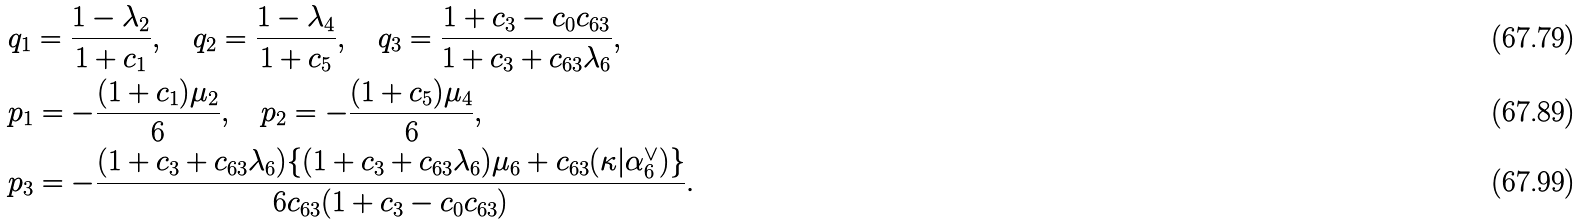Convert formula to latex. <formula><loc_0><loc_0><loc_500><loc_500>& q _ { 1 } = \frac { 1 - \lambda _ { 2 } } { 1 + c _ { 1 } } , \quad q _ { 2 } = \frac { 1 - \lambda _ { 4 } } { 1 + c _ { 5 } } , \quad q _ { 3 } = \frac { 1 + c _ { 3 } - c _ { 0 } c _ { 6 3 } } { 1 + c _ { 3 } + c _ { 6 3 } \lambda _ { 6 } } , \\ & p _ { 1 } = - \frac { ( 1 + c _ { 1 } ) \mu _ { 2 } } { 6 } , \quad p _ { 2 } = - \frac { ( 1 + c _ { 5 } ) \mu _ { 4 } } { 6 } , \\ & p _ { 3 } = - \frac { ( 1 + c _ { 3 } + c _ { 6 3 } \lambda _ { 6 } ) \{ ( 1 + c _ { 3 } + c _ { 6 3 } \lambda _ { 6 } ) \mu _ { 6 } + c _ { 6 3 } ( \kappa | \alpha _ { 6 } ^ { \vee } ) \} } { 6 c _ { 6 3 } ( 1 + c _ { 3 } - c _ { 0 } c _ { 6 3 } ) } .</formula> 